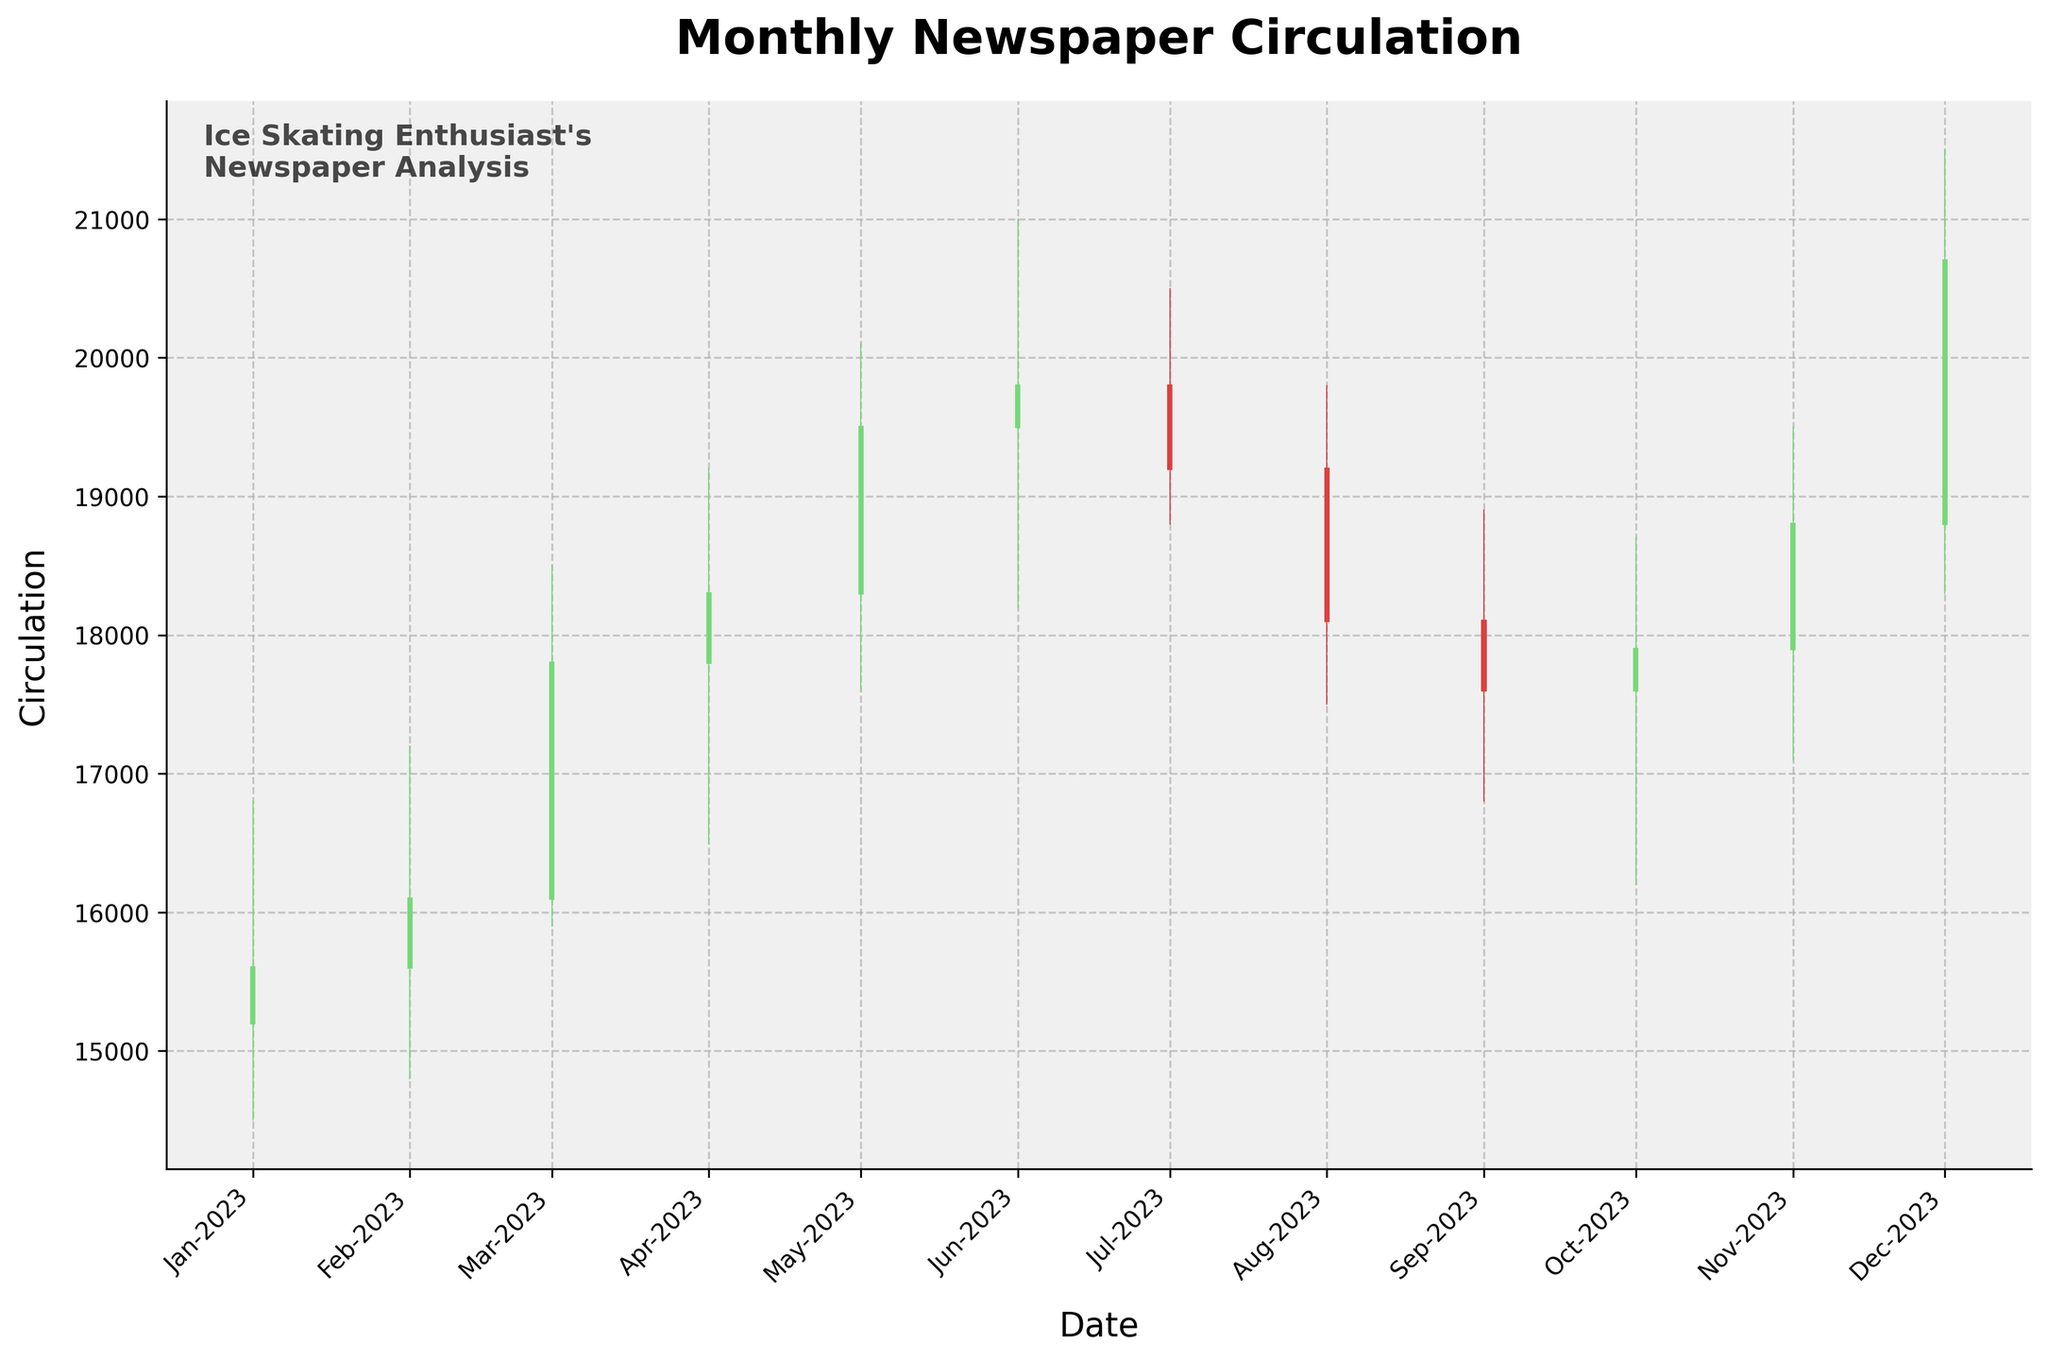What is the highest circulation recorded in 2023? The highest circulation can be found by identifying the peak value in the 'High' data points on the chart. The maximum value is in December 2023 with a high of 21500.
Answer: 21500 How many months show an increase in circulation from the beginning to the end of the month? An increase in circulation is indicated when the 'Close' value is higher than the 'Open' value. Count the months where 'Close' > 'Open'. These months are Feb, Mar, Apr, May, Jun, Nov, and Dec (7 months in total).
Answer: 7 months Which month had the lowest 'Low' circulation value and what was it? Examine the 'Low' data points to identify the lowest circulation value. The minimum 'Low' value is 14500 in January 2023.
Answer: January, 14500 Between which two consecutive months was the largest drop in the 'Close' value observed? Calculate the differences in 'Close' values for each consecutive month and find the maximum drop. The largest drop occurs between June and July (19800 to 19200, a drop of 600).
Answer: June to July What is the average 'Open' circulation value over the year? Sum all the 'Open' values and then divide by the number of months (12). The sum of 'Open' values is 175700, so the average is 175700 / 12 = 14641.67.
Answer: 14641.67 Which months had their highest value in the 'High' data point greater than 20000? Identify months where the 'High' value exceeds 20000. These months are May and December with 'High' values of 20100 and 21500 respectively.
Answer: May, December In which month did the circulation end lower than it started? Identify months where the 'Close' value is less than the 'Open' value. These months are Jul, Aug, and Sep.
Answer: Jul, Aug, Sep What is the median 'Close' value of the newspaper circulation for the year 2023? Order the 'Close' values and find the middle value. The ordered 'Close' values are: 15600, 16100, 17600, 17800, 17900, 18100, 18300, 18800, 19200, 19500, 19800, 20700. The median is the average of the 6th and 7th values (18100 and 18300), so (18100 + 18300) / 2 = 18200.
Answer: 18200 In which month did the newspaper circulation have both its highest and lowest values of the year? Review the 'High' and 'Low' values to identify any month that holds both the highest 'High' and the lowest 'Low'. January has the lowest 'Low' (14500) but not the highest 'High'. December has the highest 'High' (21500), so it is the correct month.
Answer: December What was the overall trend in newspaper circulation from January to December 2023? Compare the 'Open' value of January to the 'Close' value of December. January started at 15200 and December ended at 20700, indicating an overall upward trend.
Answer: Upward trend 